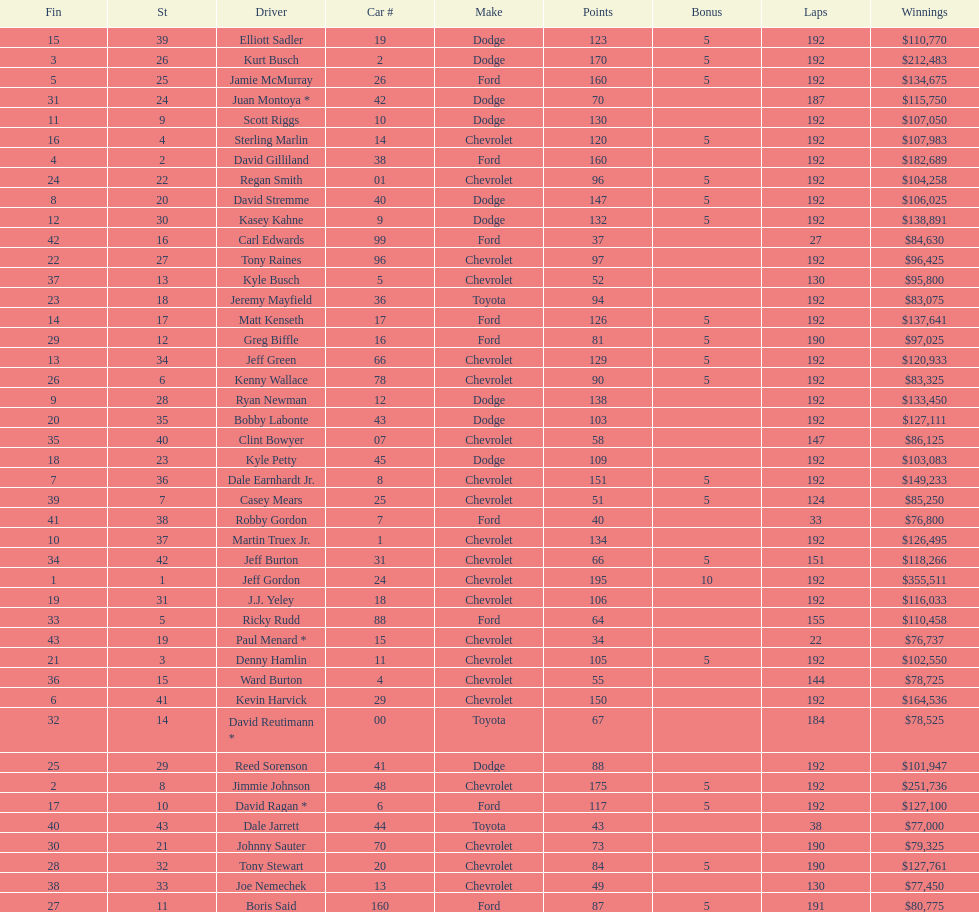How many drivers earned 5 bonus each in the race? 19. 